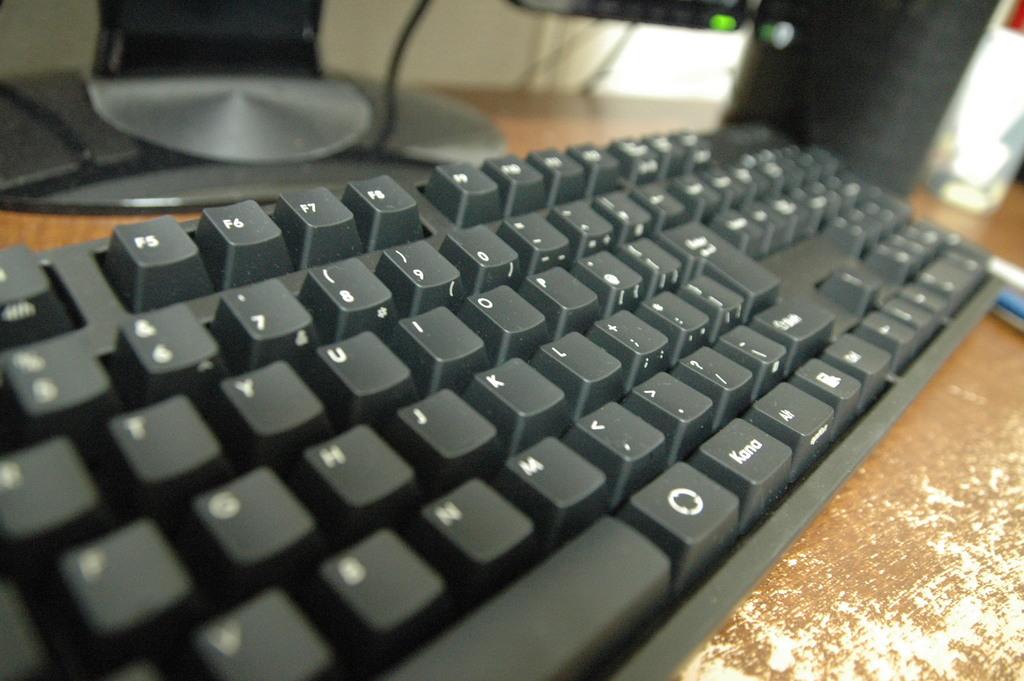What key is to the right of the f5 key?
Offer a very short reply. F6. 